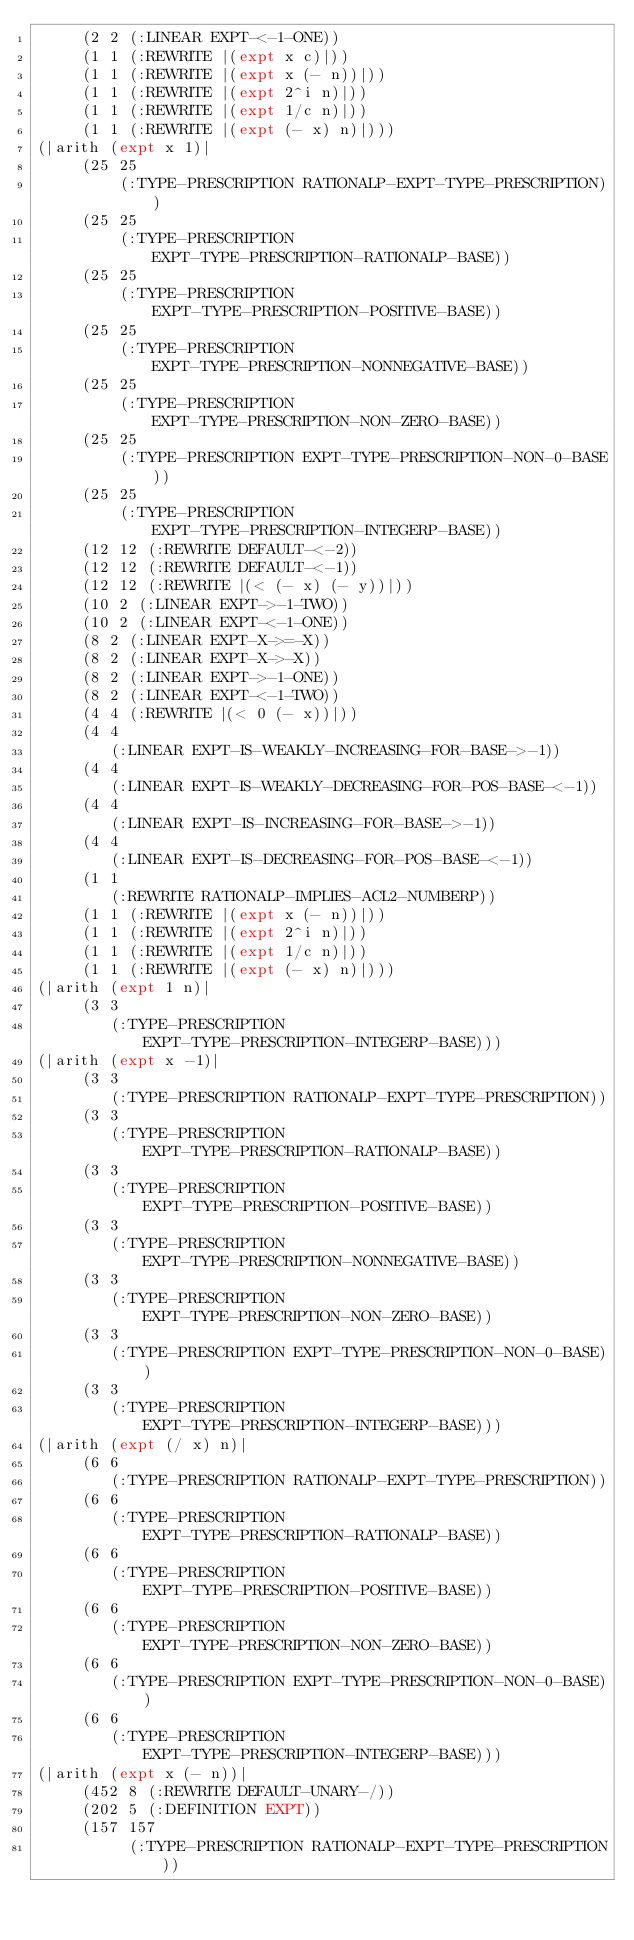<code> <loc_0><loc_0><loc_500><loc_500><_Lisp_>     (2 2 (:LINEAR EXPT-<-1-ONE))
     (1 1 (:REWRITE |(expt x c)|))
     (1 1 (:REWRITE |(expt x (- n))|))
     (1 1 (:REWRITE |(expt 2^i n)|))
     (1 1 (:REWRITE |(expt 1/c n)|))
     (1 1 (:REWRITE |(expt (- x) n)|)))
(|arith (expt x 1)|
     (25 25
         (:TYPE-PRESCRIPTION RATIONALP-EXPT-TYPE-PRESCRIPTION))
     (25 25
         (:TYPE-PRESCRIPTION EXPT-TYPE-PRESCRIPTION-RATIONALP-BASE))
     (25 25
         (:TYPE-PRESCRIPTION EXPT-TYPE-PRESCRIPTION-POSITIVE-BASE))
     (25 25
         (:TYPE-PRESCRIPTION EXPT-TYPE-PRESCRIPTION-NONNEGATIVE-BASE))
     (25 25
         (:TYPE-PRESCRIPTION EXPT-TYPE-PRESCRIPTION-NON-ZERO-BASE))
     (25 25
         (:TYPE-PRESCRIPTION EXPT-TYPE-PRESCRIPTION-NON-0-BASE))
     (25 25
         (:TYPE-PRESCRIPTION EXPT-TYPE-PRESCRIPTION-INTEGERP-BASE))
     (12 12 (:REWRITE DEFAULT-<-2))
     (12 12 (:REWRITE DEFAULT-<-1))
     (12 12 (:REWRITE |(< (- x) (- y))|))
     (10 2 (:LINEAR EXPT->-1-TWO))
     (10 2 (:LINEAR EXPT-<-1-ONE))
     (8 2 (:LINEAR EXPT-X->=-X))
     (8 2 (:LINEAR EXPT-X->-X))
     (8 2 (:LINEAR EXPT->-1-ONE))
     (8 2 (:LINEAR EXPT-<-1-TWO))
     (4 4 (:REWRITE |(< 0 (- x))|))
     (4 4
        (:LINEAR EXPT-IS-WEAKLY-INCREASING-FOR-BASE->-1))
     (4 4
        (:LINEAR EXPT-IS-WEAKLY-DECREASING-FOR-POS-BASE-<-1))
     (4 4
        (:LINEAR EXPT-IS-INCREASING-FOR-BASE->-1))
     (4 4
        (:LINEAR EXPT-IS-DECREASING-FOR-POS-BASE-<-1))
     (1 1
        (:REWRITE RATIONALP-IMPLIES-ACL2-NUMBERP))
     (1 1 (:REWRITE |(expt x (- n))|))
     (1 1 (:REWRITE |(expt 2^i n)|))
     (1 1 (:REWRITE |(expt 1/c n)|))
     (1 1 (:REWRITE |(expt (- x) n)|)))
(|arith (expt 1 n)|
     (3 3
        (:TYPE-PRESCRIPTION EXPT-TYPE-PRESCRIPTION-INTEGERP-BASE)))
(|arith (expt x -1)|
     (3 3
        (:TYPE-PRESCRIPTION RATIONALP-EXPT-TYPE-PRESCRIPTION))
     (3 3
        (:TYPE-PRESCRIPTION EXPT-TYPE-PRESCRIPTION-RATIONALP-BASE))
     (3 3
        (:TYPE-PRESCRIPTION EXPT-TYPE-PRESCRIPTION-POSITIVE-BASE))
     (3 3
        (:TYPE-PRESCRIPTION EXPT-TYPE-PRESCRIPTION-NONNEGATIVE-BASE))
     (3 3
        (:TYPE-PRESCRIPTION EXPT-TYPE-PRESCRIPTION-NON-ZERO-BASE))
     (3 3
        (:TYPE-PRESCRIPTION EXPT-TYPE-PRESCRIPTION-NON-0-BASE))
     (3 3
        (:TYPE-PRESCRIPTION EXPT-TYPE-PRESCRIPTION-INTEGERP-BASE)))
(|arith (expt (/ x) n)|
     (6 6
        (:TYPE-PRESCRIPTION RATIONALP-EXPT-TYPE-PRESCRIPTION))
     (6 6
        (:TYPE-PRESCRIPTION EXPT-TYPE-PRESCRIPTION-RATIONALP-BASE))
     (6 6
        (:TYPE-PRESCRIPTION EXPT-TYPE-PRESCRIPTION-POSITIVE-BASE))
     (6 6
        (:TYPE-PRESCRIPTION EXPT-TYPE-PRESCRIPTION-NON-ZERO-BASE))
     (6 6
        (:TYPE-PRESCRIPTION EXPT-TYPE-PRESCRIPTION-NON-0-BASE))
     (6 6
        (:TYPE-PRESCRIPTION EXPT-TYPE-PRESCRIPTION-INTEGERP-BASE)))
(|arith (expt x (- n))|
     (452 8 (:REWRITE DEFAULT-UNARY-/))
     (202 5 (:DEFINITION EXPT))
     (157 157
          (:TYPE-PRESCRIPTION RATIONALP-EXPT-TYPE-PRESCRIPTION))</code> 